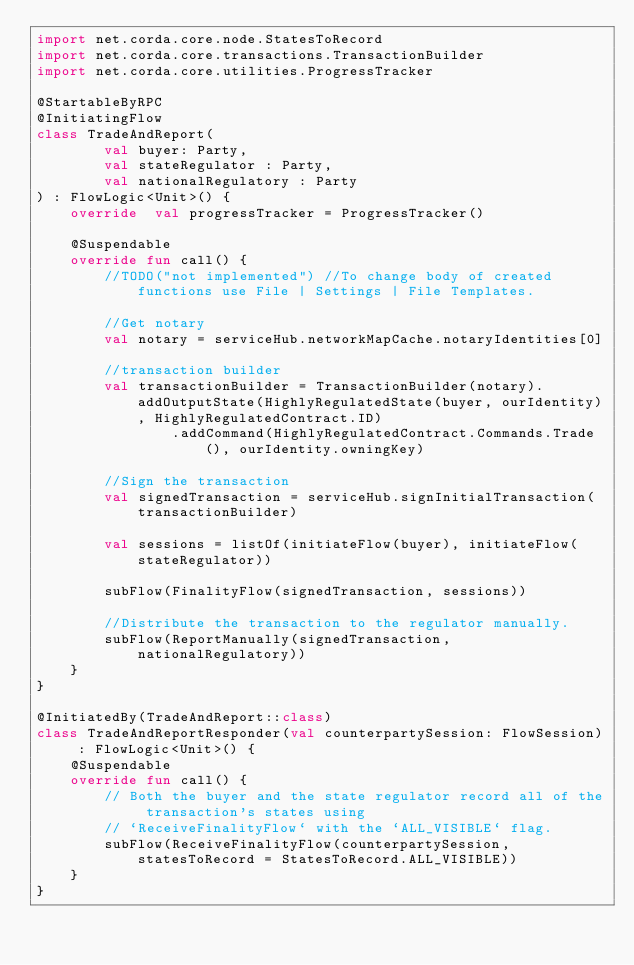Convert code to text. <code><loc_0><loc_0><loc_500><loc_500><_Kotlin_>import net.corda.core.node.StatesToRecord
import net.corda.core.transactions.TransactionBuilder
import net.corda.core.utilities.ProgressTracker

@StartableByRPC
@InitiatingFlow
class TradeAndReport(
        val buyer: Party,
        val stateRegulator : Party,
        val nationalRegulatory : Party
) : FlowLogic<Unit>() {
    override  val progressTracker = ProgressTracker()

    @Suspendable
    override fun call() {
        //TODO("not implemented") //To change body of created functions use File | Settings | File Templates.

        //Get notary
        val notary = serviceHub.networkMapCache.notaryIdentities[0]

        //transaction builder
        val transactionBuilder = TransactionBuilder(notary).addOutputState(HighlyRegulatedState(buyer, ourIdentity), HighlyRegulatedContract.ID)
                .addCommand(HighlyRegulatedContract.Commands.Trade(), ourIdentity.owningKey)

        //Sign the transaction
        val signedTransaction = serviceHub.signInitialTransaction(transactionBuilder)

        val sessions = listOf(initiateFlow(buyer), initiateFlow(stateRegulator))

        subFlow(FinalityFlow(signedTransaction, sessions))

        //Distribute the transaction to the regulator manually.
        subFlow(ReportManually(signedTransaction, nationalRegulatory))
    }
}

@InitiatedBy(TradeAndReport::class)
class TradeAndReportResponder(val counterpartySession: FlowSession) : FlowLogic<Unit>() {
    @Suspendable
    override fun call() {
        // Both the buyer and the state regulator record all of the transaction's states using
        // `ReceiveFinalityFlow` with the `ALL_VISIBLE` flag.
        subFlow(ReceiveFinalityFlow(counterpartySession, statesToRecord = StatesToRecord.ALL_VISIBLE))
    }
}</code> 